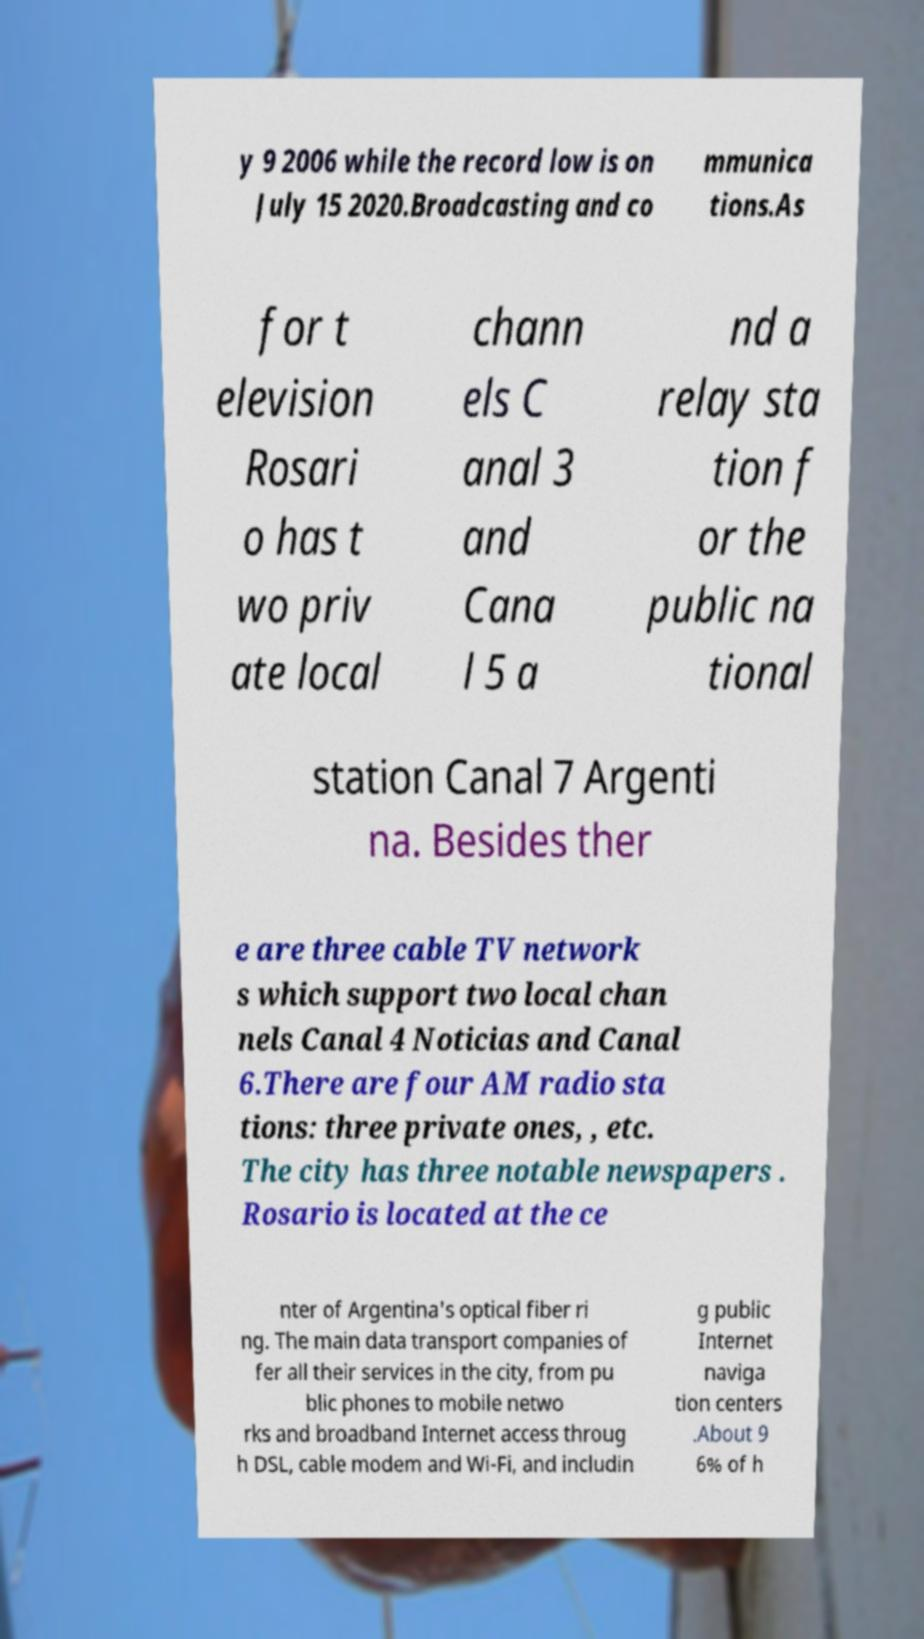Could you extract and type out the text from this image? y 9 2006 while the record low is on July 15 2020.Broadcasting and co mmunica tions.As for t elevision Rosari o has t wo priv ate local chann els C anal 3 and Cana l 5 a nd a relay sta tion f or the public na tional station Canal 7 Argenti na. Besides ther e are three cable TV network s which support two local chan nels Canal 4 Noticias and Canal 6.There are four AM radio sta tions: three private ones, , etc. The city has three notable newspapers . Rosario is located at the ce nter of Argentina's optical fiber ri ng. The main data transport companies of fer all their services in the city, from pu blic phones to mobile netwo rks and broadband Internet access throug h DSL, cable modem and Wi-Fi, and includin g public Internet naviga tion centers .About 9 6% of h 